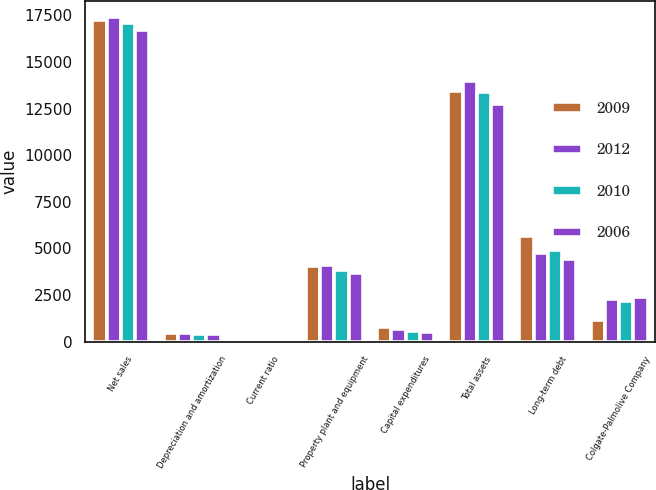<chart> <loc_0><loc_0><loc_500><loc_500><stacked_bar_chart><ecel><fcel>Net sales<fcel>Depreciation and amortization<fcel>Current ratio<fcel>Property plant and equipment<fcel>Capital expenditures<fcel>Total assets<fcel>Long-term debt<fcel>Colgate-Palmolive Company<nl><fcel>2009<fcel>17277<fcel>442<fcel>1.2<fcel>4080<fcel>757<fcel>13459<fcel>5644<fcel>1145<nl><fcel>2012<fcel>17420<fcel>439<fcel>1.1<fcel>4083<fcel>670<fcel>13985<fcel>4749<fcel>2305<nl><fcel>2010<fcel>17085<fcel>425<fcel>1.2<fcel>3842<fcel>565<fcel>13394<fcel>4926<fcel>2189<nl><fcel>2006<fcel>16734<fcel>421<fcel>1.2<fcel>3668<fcel>537<fcel>12724<fcel>4430<fcel>2375<nl></chart> 